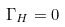<formula> <loc_0><loc_0><loc_500><loc_500>\Gamma _ { H } = 0</formula> 